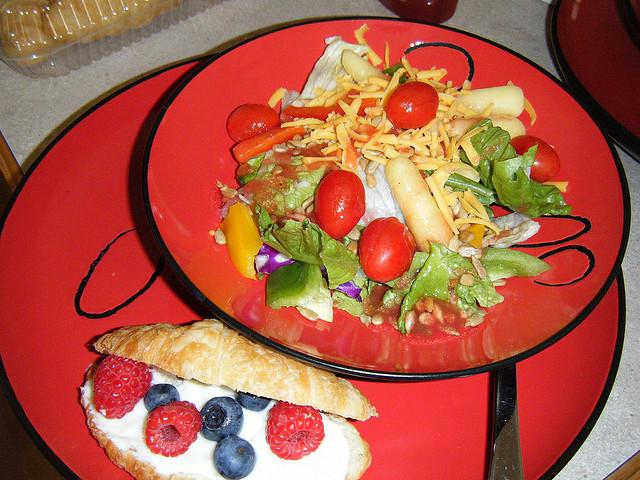What are the red berries?
Keep it brief. Raspberries. What shape is the plate?
Be succinct. Circle. What is the red fruit that garnishes the plate?
Keep it brief. Raspberries. Are there any spring rolls on the plates?
Answer briefly. No. 